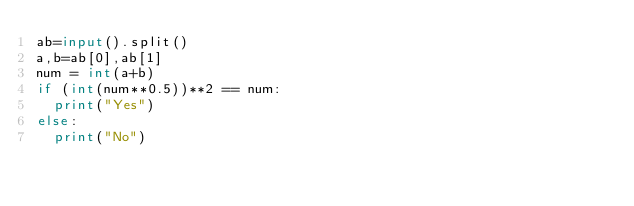Convert code to text. <code><loc_0><loc_0><loc_500><loc_500><_Python_>ab=input().split()
a,b=ab[0],ab[1]
num = int(a+b)
if (int(num**0.5))**2 == num:
  print("Yes")
else:
  print("No")</code> 